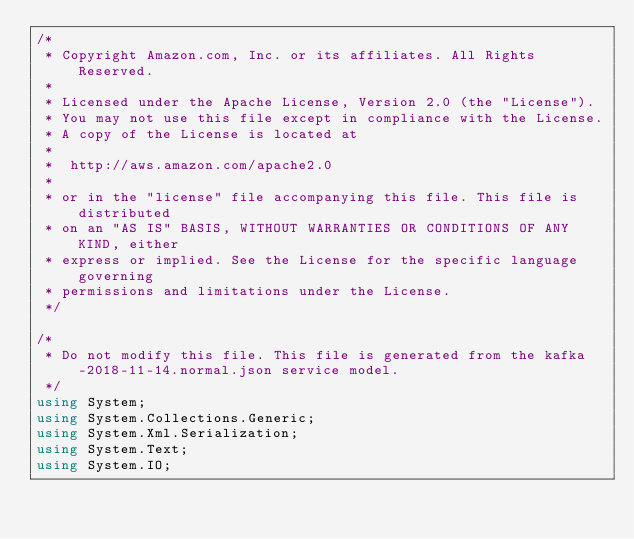<code> <loc_0><loc_0><loc_500><loc_500><_C#_>/*
 * Copyright Amazon.com, Inc. or its affiliates. All Rights Reserved.
 * 
 * Licensed under the Apache License, Version 2.0 (the "License").
 * You may not use this file except in compliance with the License.
 * A copy of the License is located at
 * 
 *  http://aws.amazon.com/apache2.0
 * 
 * or in the "license" file accompanying this file. This file is distributed
 * on an "AS IS" BASIS, WITHOUT WARRANTIES OR CONDITIONS OF ANY KIND, either
 * express or implied. See the License for the specific language governing
 * permissions and limitations under the License.
 */

/*
 * Do not modify this file. This file is generated from the kafka-2018-11-14.normal.json service model.
 */
using System;
using System.Collections.Generic;
using System.Xml.Serialization;
using System.Text;
using System.IO;</code> 